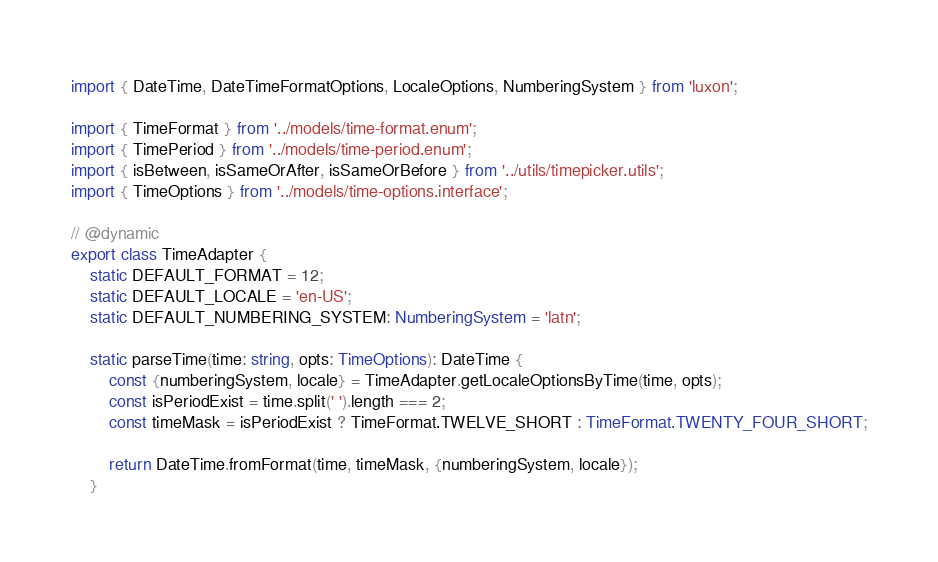Convert code to text. <code><loc_0><loc_0><loc_500><loc_500><_TypeScript_>import { DateTime, DateTimeFormatOptions, LocaleOptions, NumberingSystem } from 'luxon';

import { TimeFormat } from '../models/time-format.enum';
import { TimePeriod } from '../models/time-period.enum';
import { isBetween, isSameOrAfter, isSameOrBefore } from '../utils/timepicker.utils';
import { TimeOptions } from '../models/time-options.interface';

// @dynamic
export class TimeAdapter {
    static DEFAULT_FORMAT = 12;
    static DEFAULT_LOCALE = 'en-US';
    static DEFAULT_NUMBERING_SYSTEM: NumberingSystem = 'latn';

    static parseTime(time: string, opts: TimeOptions): DateTime {
        const {numberingSystem, locale} = TimeAdapter.getLocaleOptionsByTime(time, opts);
        const isPeriodExist = time.split(' ').length === 2;
        const timeMask = isPeriodExist ? TimeFormat.TWELVE_SHORT : TimeFormat.TWENTY_FOUR_SHORT;

        return DateTime.fromFormat(time, timeMask, {numberingSystem, locale});
    }
</code> 